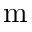<formula> <loc_0><loc_0><loc_500><loc_500>m</formula> 